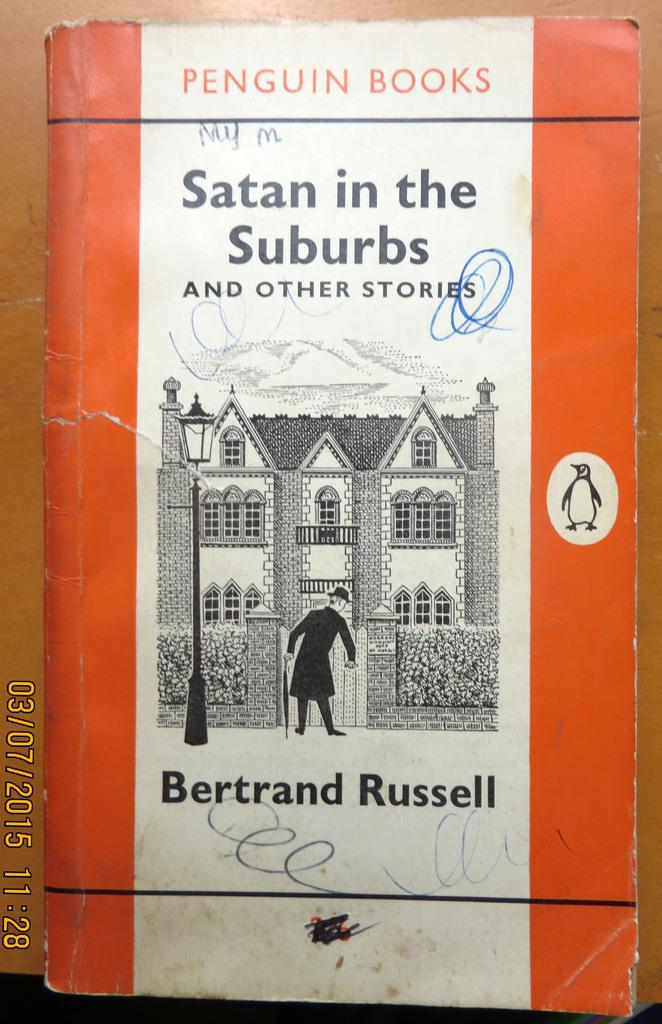Provide a one-sentence caption for the provided image. A Penguin Book titles, "Satan in the Suburbs.". 